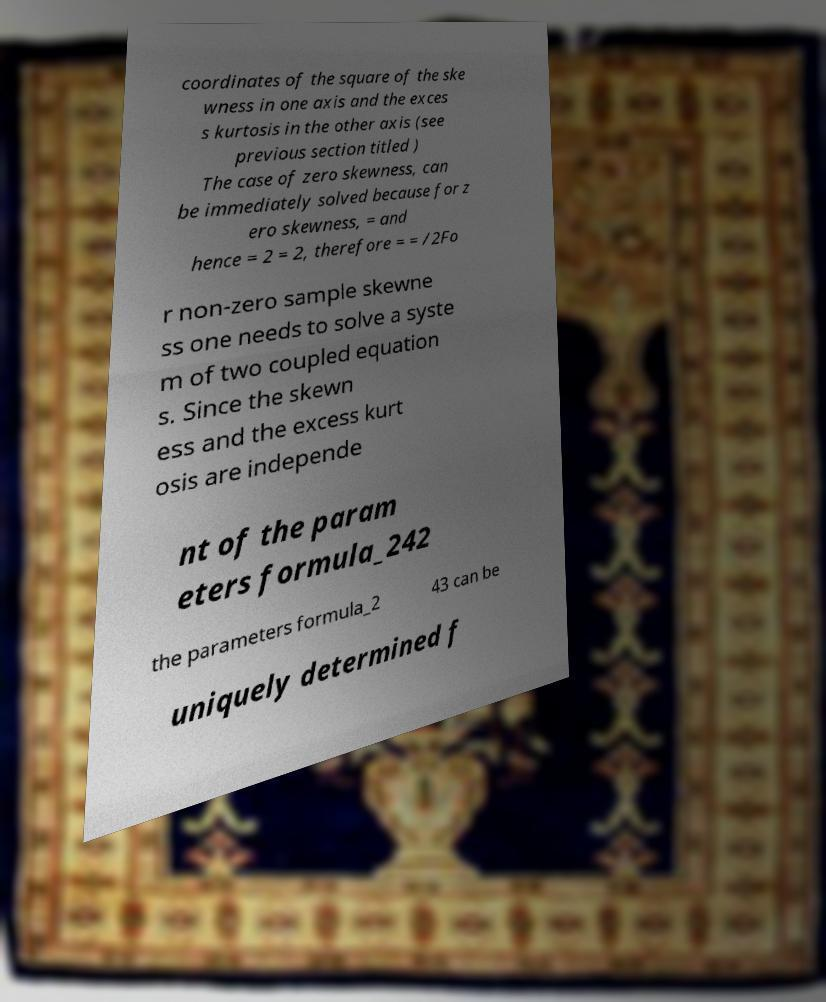There's text embedded in this image that I need extracted. Can you transcribe it verbatim? coordinates of the square of the ske wness in one axis and the exces s kurtosis in the other axis (see previous section titled ) The case of zero skewness, can be immediately solved because for z ero skewness, = and hence = 2 = 2, therefore = = /2Fo r non-zero sample skewne ss one needs to solve a syste m of two coupled equation s. Since the skewn ess and the excess kurt osis are independe nt of the param eters formula_242 the parameters formula_2 43 can be uniquely determined f 